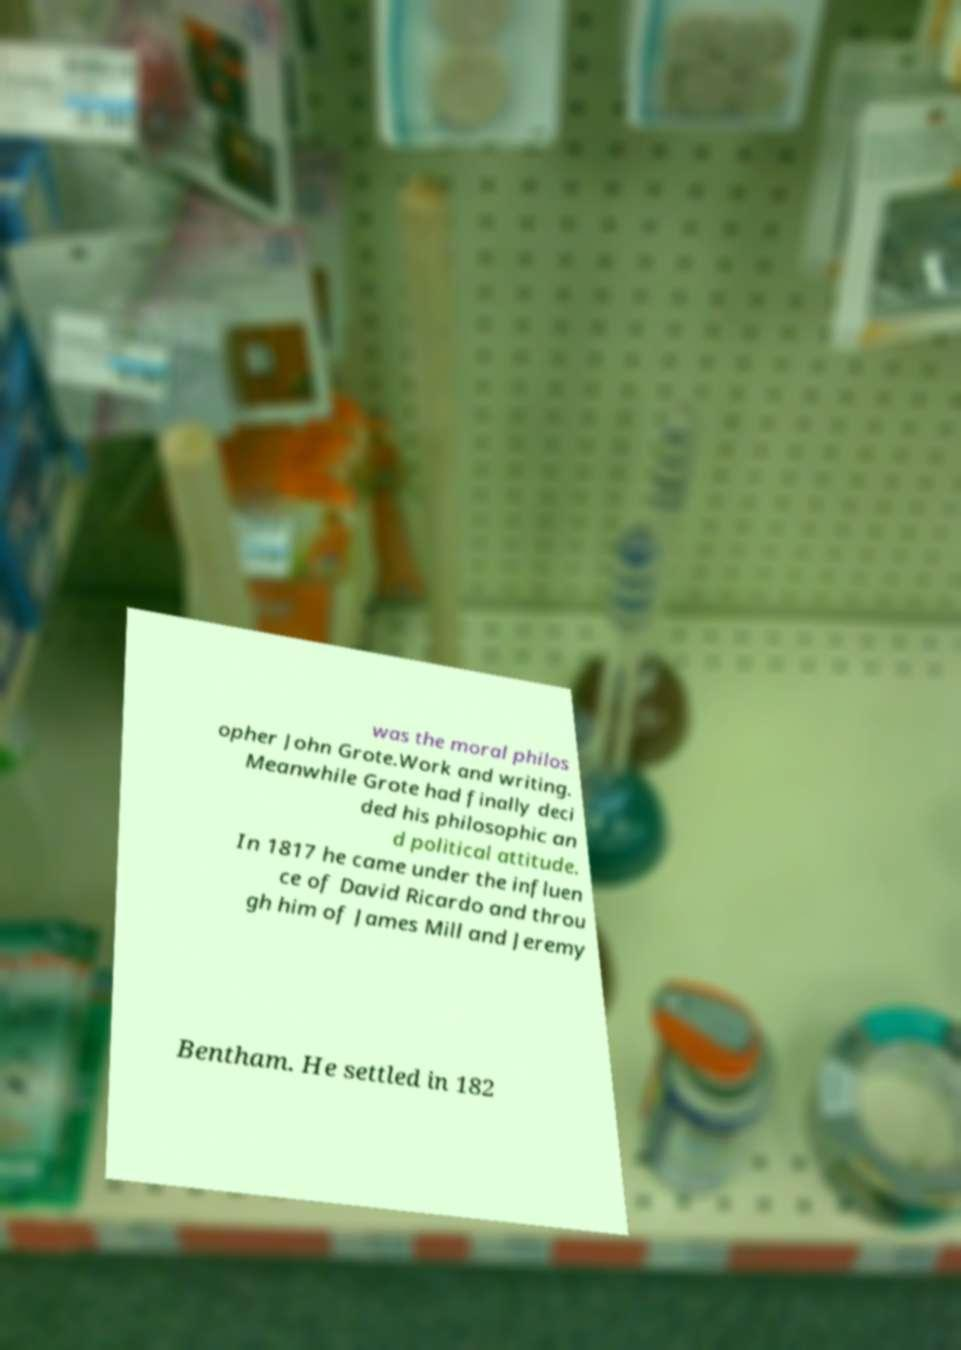For documentation purposes, I need the text within this image transcribed. Could you provide that? was the moral philos opher John Grote.Work and writing. Meanwhile Grote had finally deci ded his philosophic an d political attitude. In 1817 he came under the influen ce of David Ricardo and throu gh him of James Mill and Jeremy Bentham. He settled in 182 